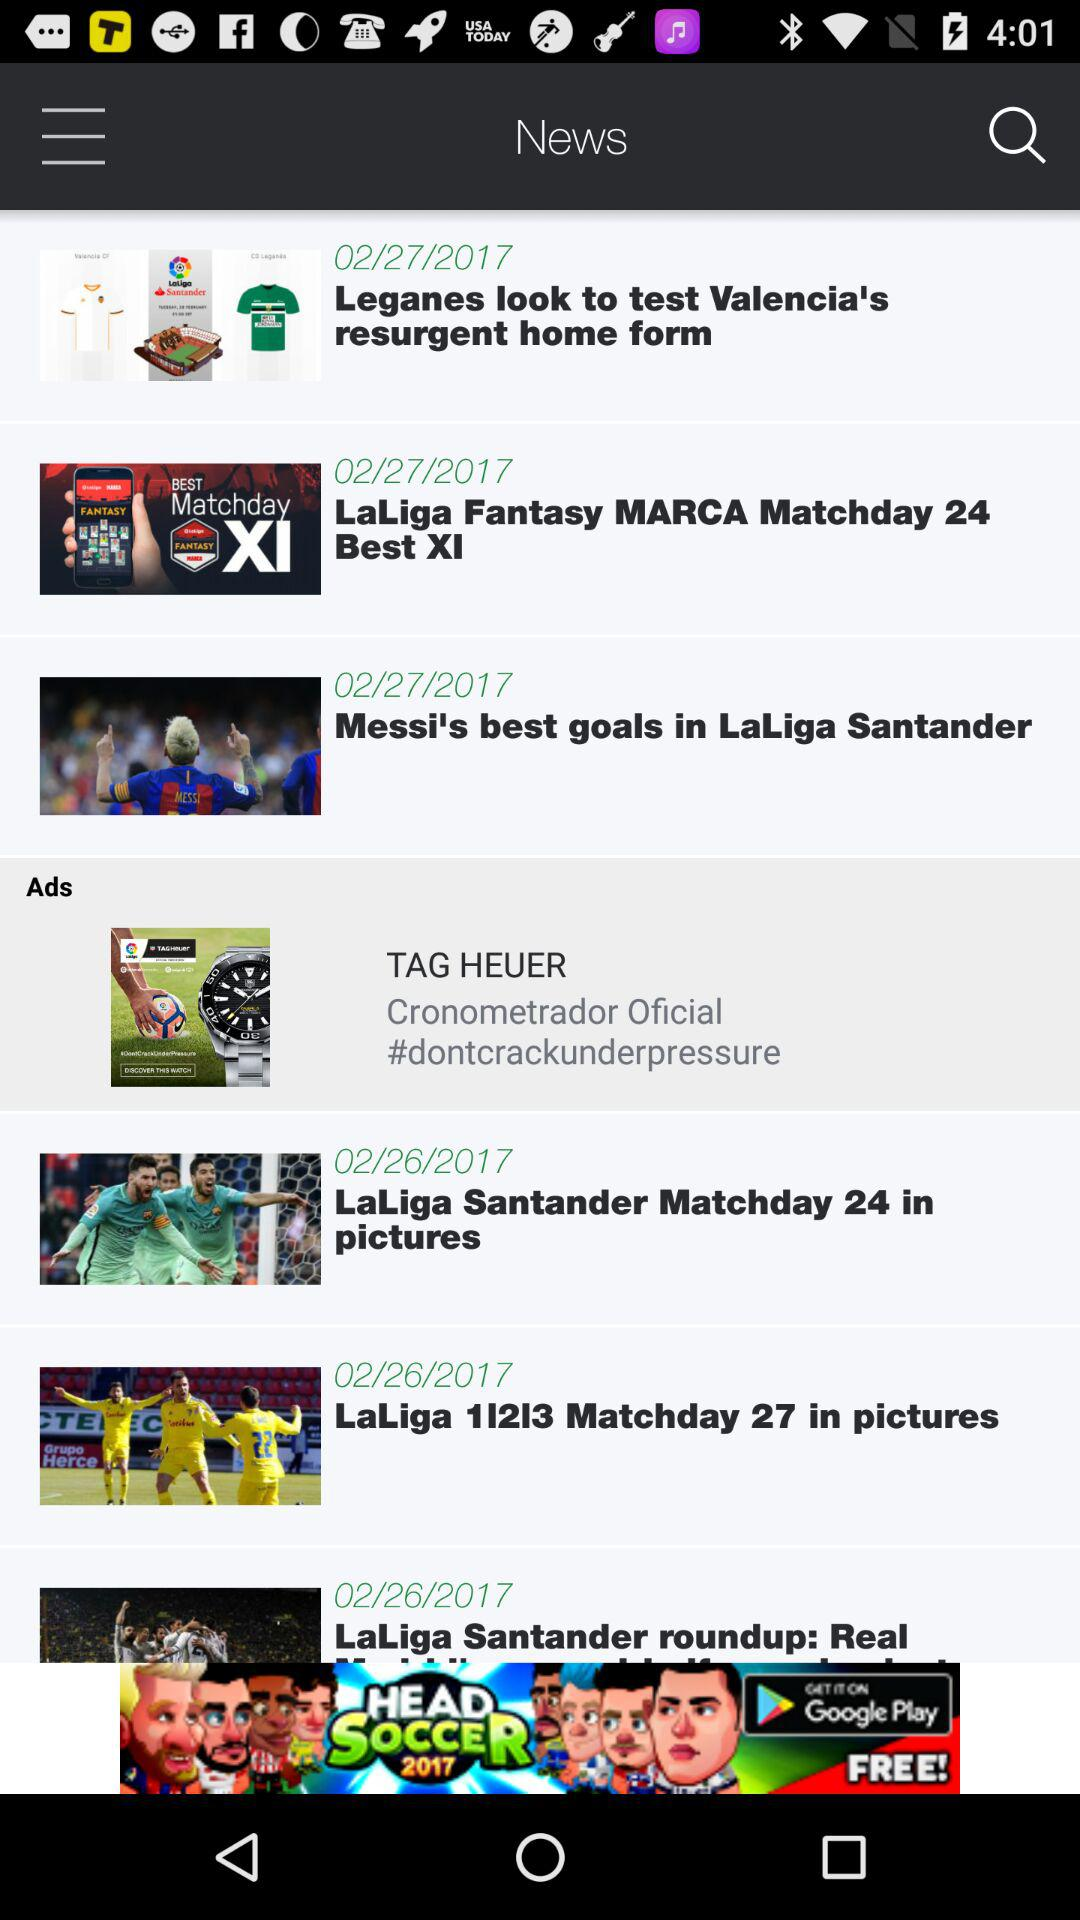On which date was the news "Leganes look to test Valencia's resurgent home form" posted? The news "Leganes look to test Valencia's resurgent home form" was posted on February 27, 2017. 